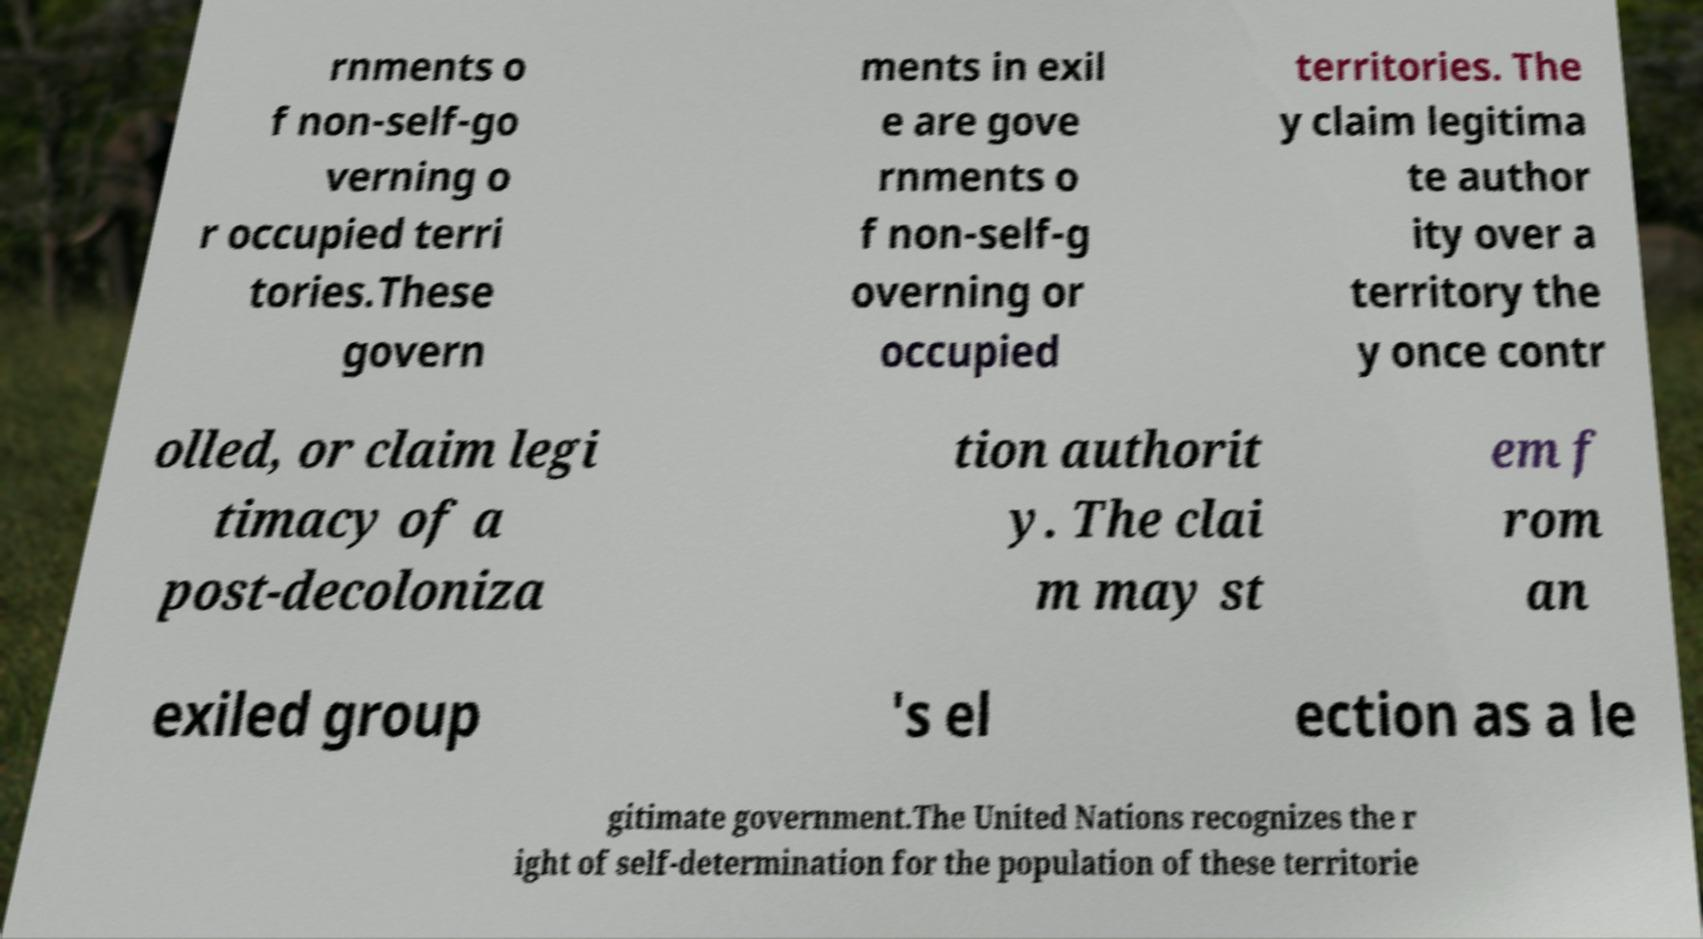Please identify and transcribe the text found in this image. rnments o f non-self-go verning o r occupied terri tories.These govern ments in exil e are gove rnments o f non-self-g overning or occupied territories. The y claim legitima te author ity over a territory the y once contr olled, or claim legi timacy of a post-decoloniza tion authorit y. The clai m may st em f rom an exiled group 's el ection as a le gitimate government.The United Nations recognizes the r ight of self-determination for the population of these territorie 